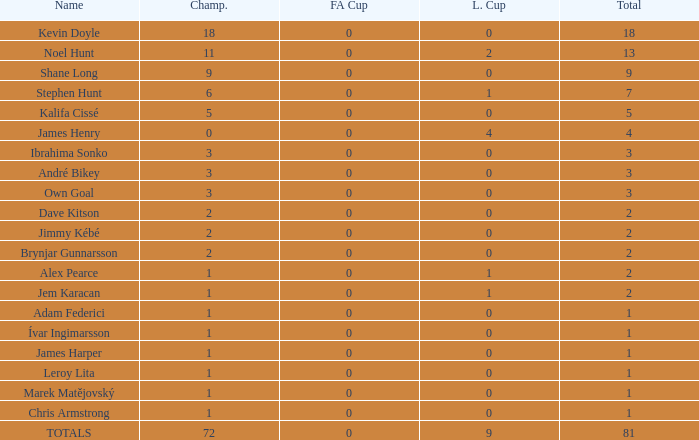What is the total championships of James Henry that has a league cup more than 1? 0.0. 